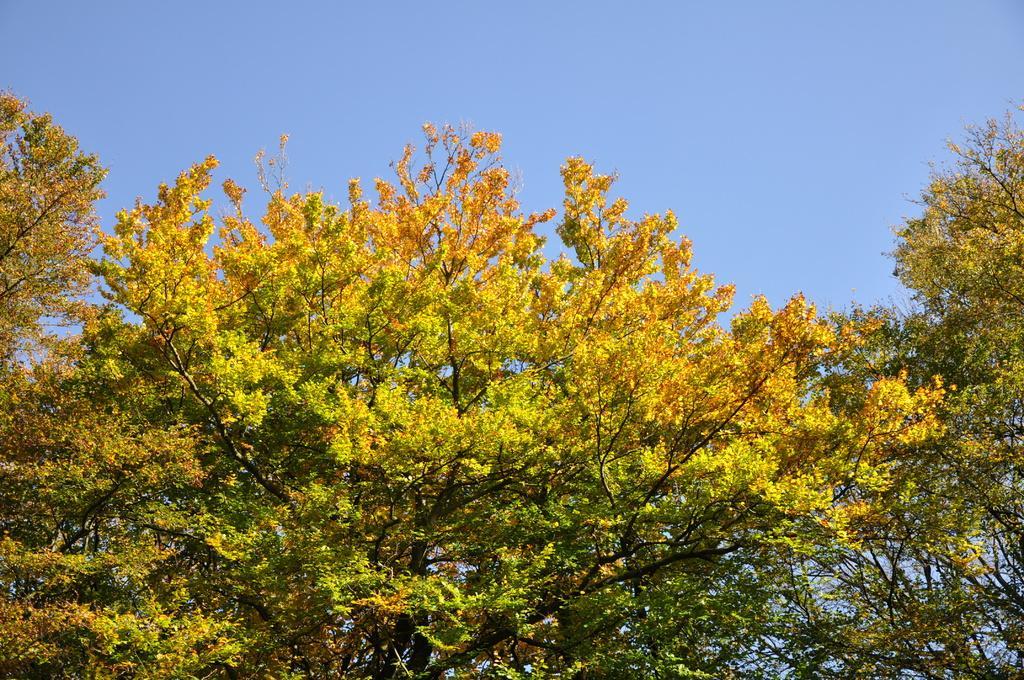Could you give a brief overview of what you see in this image? In this image we can see the trees. Behind the trees we can see the sky. 